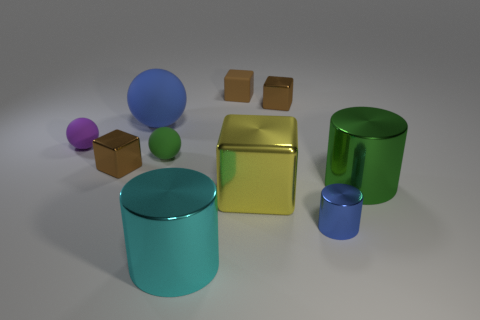Is the color of the large matte ball the same as the tiny metal cylinder?
Ensure brevity in your answer.  Yes. What is the shape of the small brown metal thing that is behind the large blue ball?
Offer a terse response. Cube. The large metallic cube is what color?
Offer a terse response. Yellow. There is a yellow thing that is the same material as the green cylinder; what shape is it?
Keep it short and to the point. Cube. There is a metallic cube to the left of the cyan cylinder; does it have the same size as the big yellow block?
Give a very brief answer. No. How many things are either small shiny things that are left of the small green sphere or large cylinders that are on the left side of the large yellow shiny block?
Ensure brevity in your answer.  2. Is the color of the tiny metal cube on the left side of the large yellow metal thing the same as the rubber cube?
Keep it short and to the point. Yes. What number of metal objects are either green cylinders or large blue objects?
Your answer should be very brief. 1. The tiny purple rubber object is what shape?
Provide a succinct answer. Sphere. Are the big green cylinder and the small blue object made of the same material?
Give a very brief answer. Yes. 